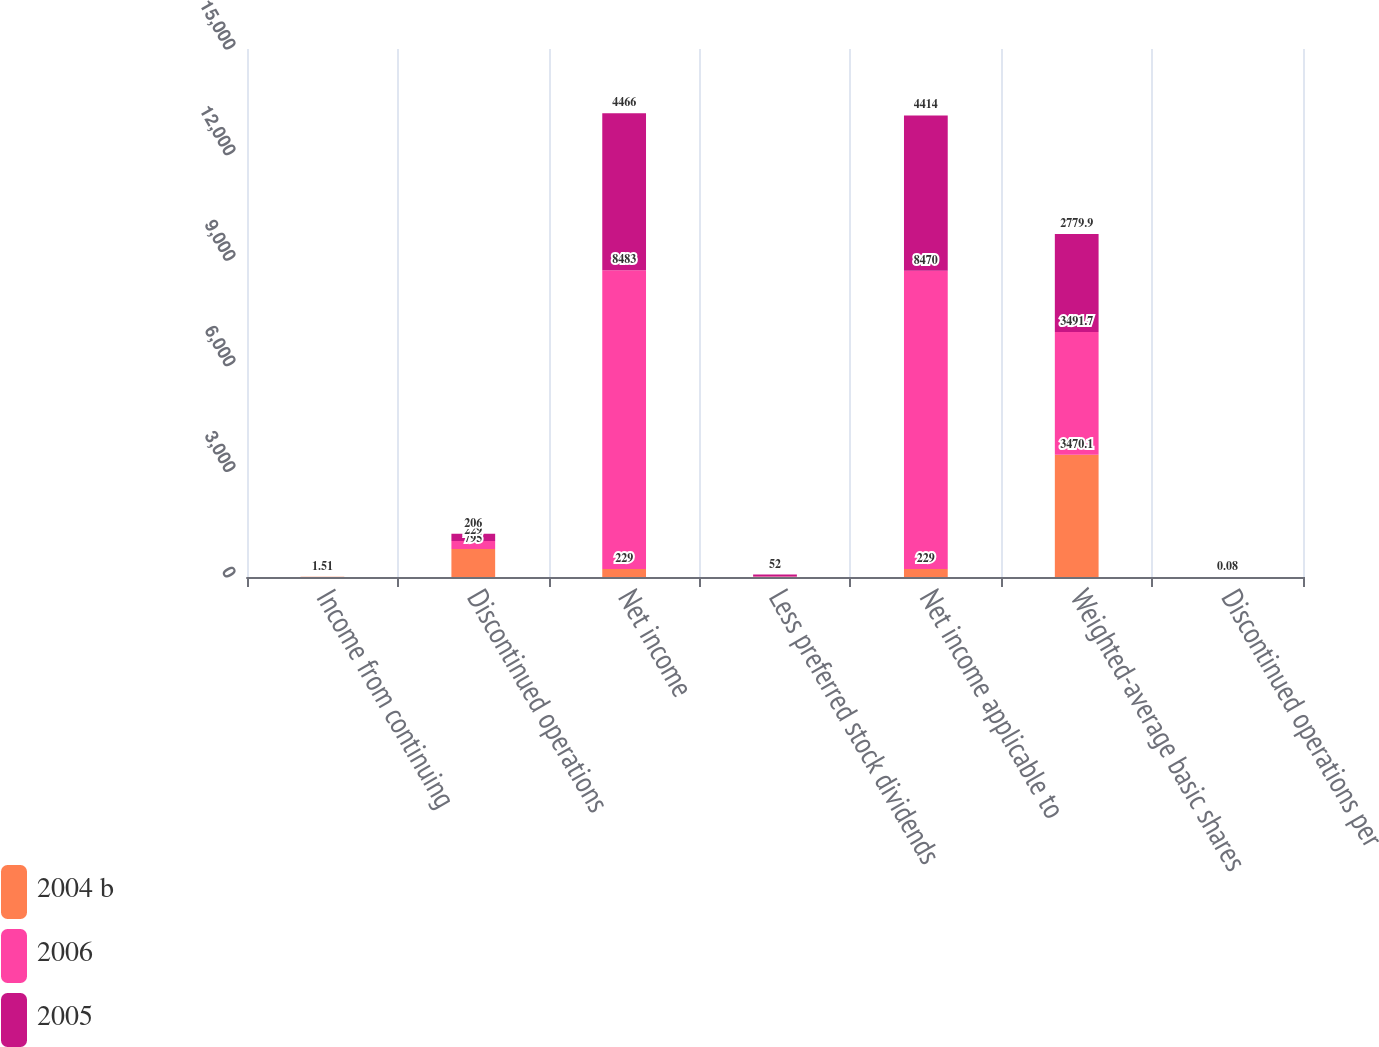Convert chart. <chart><loc_0><loc_0><loc_500><loc_500><stacked_bar_chart><ecel><fcel>Income from continuing<fcel>Discontinued operations<fcel>Net income<fcel>Less preferred stock dividends<fcel>Net income applicable to<fcel>Weighted-average basic shares<fcel>Discontinued operations per<nl><fcel>2004 b<fcel>3.93<fcel>795<fcel>229<fcel>4<fcel>229<fcel>3470.1<fcel>0.23<nl><fcel>2006<fcel>2.36<fcel>229<fcel>8483<fcel>13<fcel>8470<fcel>3491.7<fcel>0.07<nl><fcel>2005<fcel>1.51<fcel>206<fcel>4466<fcel>52<fcel>4414<fcel>2779.9<fcel>0.08<nl></chart> 